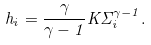<formula> <loc_0><loc_0><loc_500><loc_500>h _ { i } = \frac { \gamma } { \gamma - 1 } K \Sigma _ { i } ^ { \gamma - 1 } .</formula> 